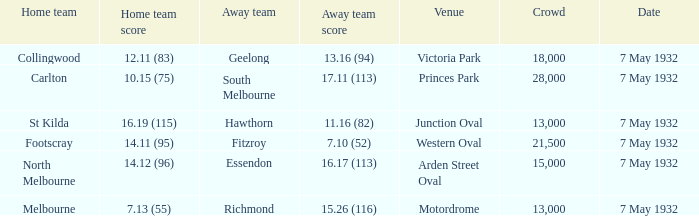For victoria park, who is the home team? Collingwood. 